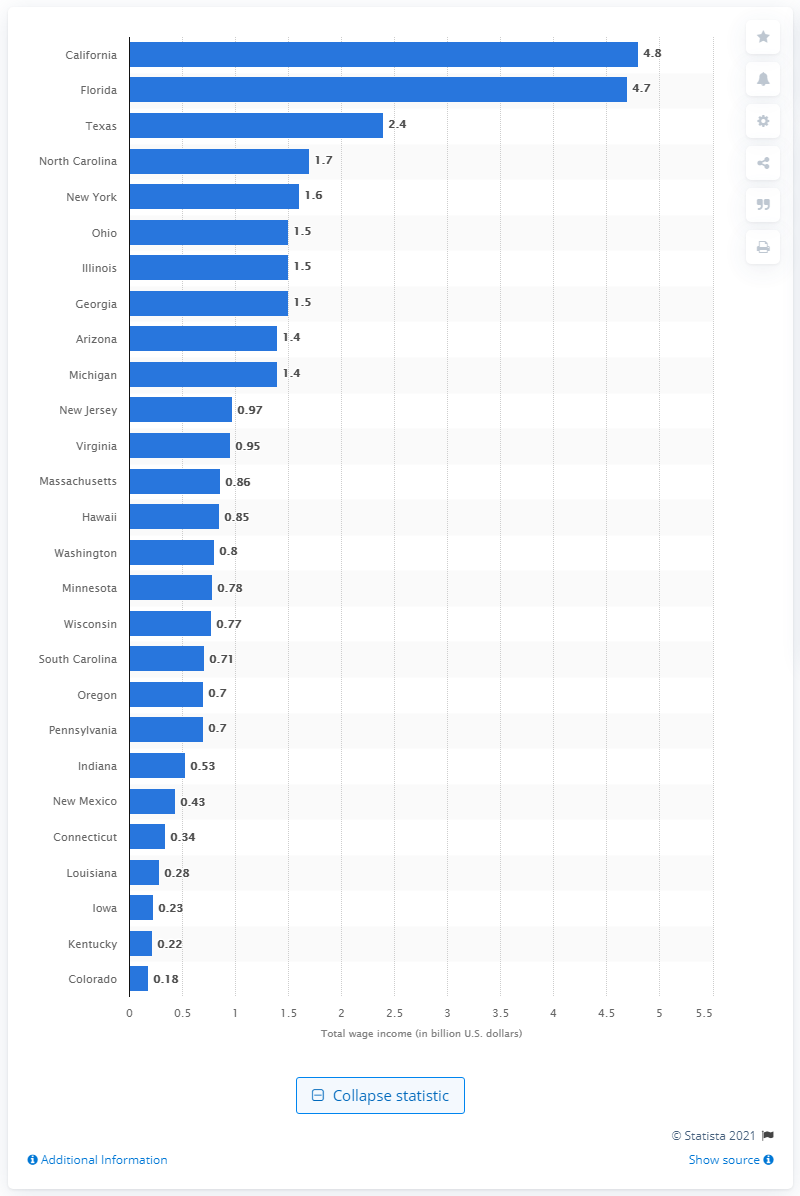Point out several critical features in this image. In 2006, the total wage income in the golf industry in New Mexico was approximately $430,000. 